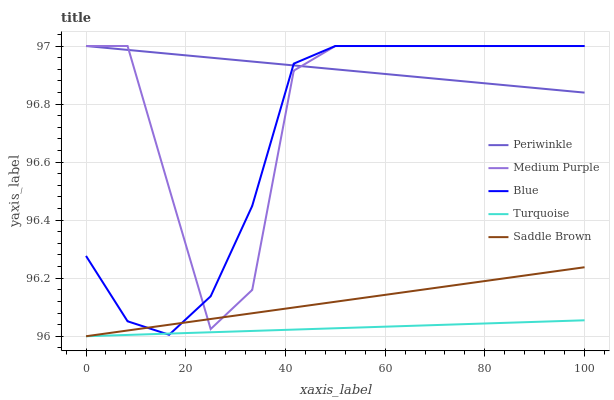Does Turquoise have the minimum area under the curve?
Answer yes or no. Yes. Does Periwinkle have the maximum area under the curve?
Answer yes or no. Yes. Does Blue have the minimum area under the curve?
Answer yes or no. No. Does Blue have the maximum area under the curve?
Answer yes or no. No. Is Periwinkle the smoothest?
Answer yes or no. Yes. Is Medium Purple the roughest?
Answer yes or no. Yes. Is Blue the smoothest?
Answer yes or no. No. Is Blue the roughest?
Answer yes or no. No. Does Turquoise have the lowest value?
Answer yes or no. Yes. Does Blue have the lowest value?
Answer yes or no. No. Does Periwinkle have the highest value?
Answer yes or no. Yes. Does Turquoise have the highest value?
Answer yes or no. No. Is Turquoise less than Medium Purple?
Answer yes or no. Yes. Is Periwinkle greater than Saddle Brown?
Answer yes or no. Yes. Does Blue intersect Medium Purple?
Answer yes or no. Yes. Is Blue less than Medium Purple?
Answer yes or no. No. Is Blue greater than Medium Purple?
Answer yes or no. No. Does Turquoise intersect Medium Purple?
Answer yes or no. No. 